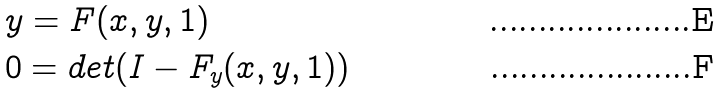Convert formula to latex. <formula><loc_0><loc_0><loc_500><loc_500>& y = F ( x , y , 1 ) \\ & 0 = d e t ( I - F _ { y } ( x , y , 1 ) )</formula> 